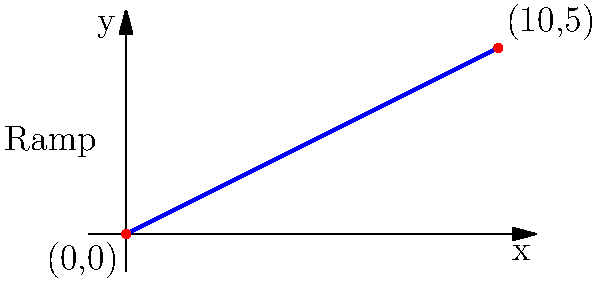As a motorcycle stunt expert, you're designing a ramp for a spectacular jump. The ramp starts at ground level (0,0) and reaches a height of 5 meters over a horizontal distance of 10 meters. What is the slope of this ramp? To find the slope of the ramp, we'll use the slope formula:

$$ \text{Slope} = \frac{\text{Change in y}}{\text{Change in x}} = \frac{y_2 - y_1}{x_2 - x_1} $$

Given:
- Start point: $(x_1, y_1) = (0, 0)$
- End point: $(x_2, y_2) = (10, 5)$

Let's plug these values into the slope formula:

$$ \text{Slope} = \frac{5 - 0}{10 - 0} = \frac{5}{10} $$

Simplifying the fraction:

$$ \text{Slope} = \frac{1}{2} = 0.5 $$

This means for every 1 unit of horizontal distance, the ramp rises 0.5 units vertically. In practical terms, for every 2 meters of horizontal distance, the ramp rises 1 meter in height.

For motorcycle stunts, it's crucial to know this slope as it affects the launch angle and speed necessary for a successful jump. A slope of 0.5 or 1:2 ratio is considered moderate and suitable for various skill levels.
Answer: $\frac{1}{2}$ or $0.5$ 